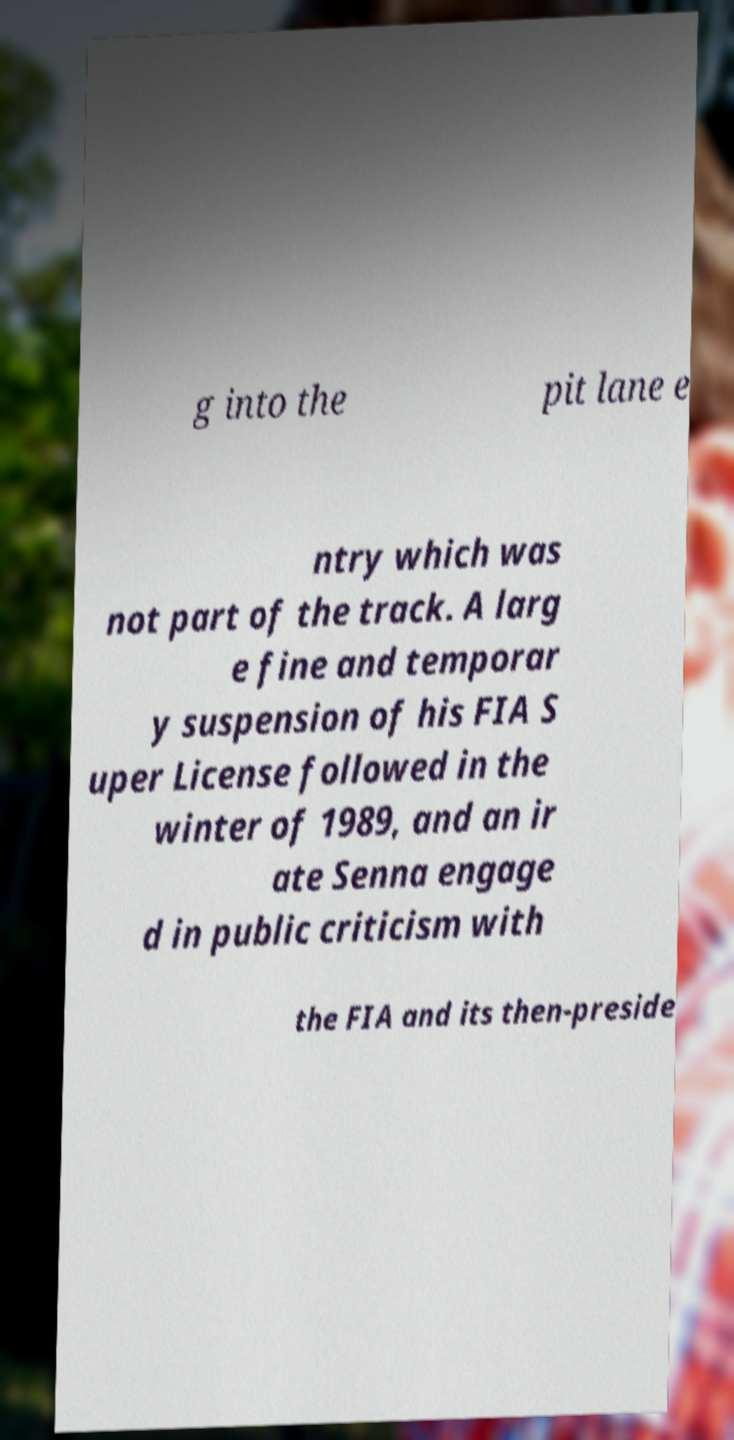Can you accurately transcribe the text from the provided image for me? g into the pit lane e ntry which was not part of the track. A larg e fine and temporar y suspension of his FIA S uper License followed in the winter of 1989, and an ir ate Senna engage d in public criticism with the FIA and its then-preside 